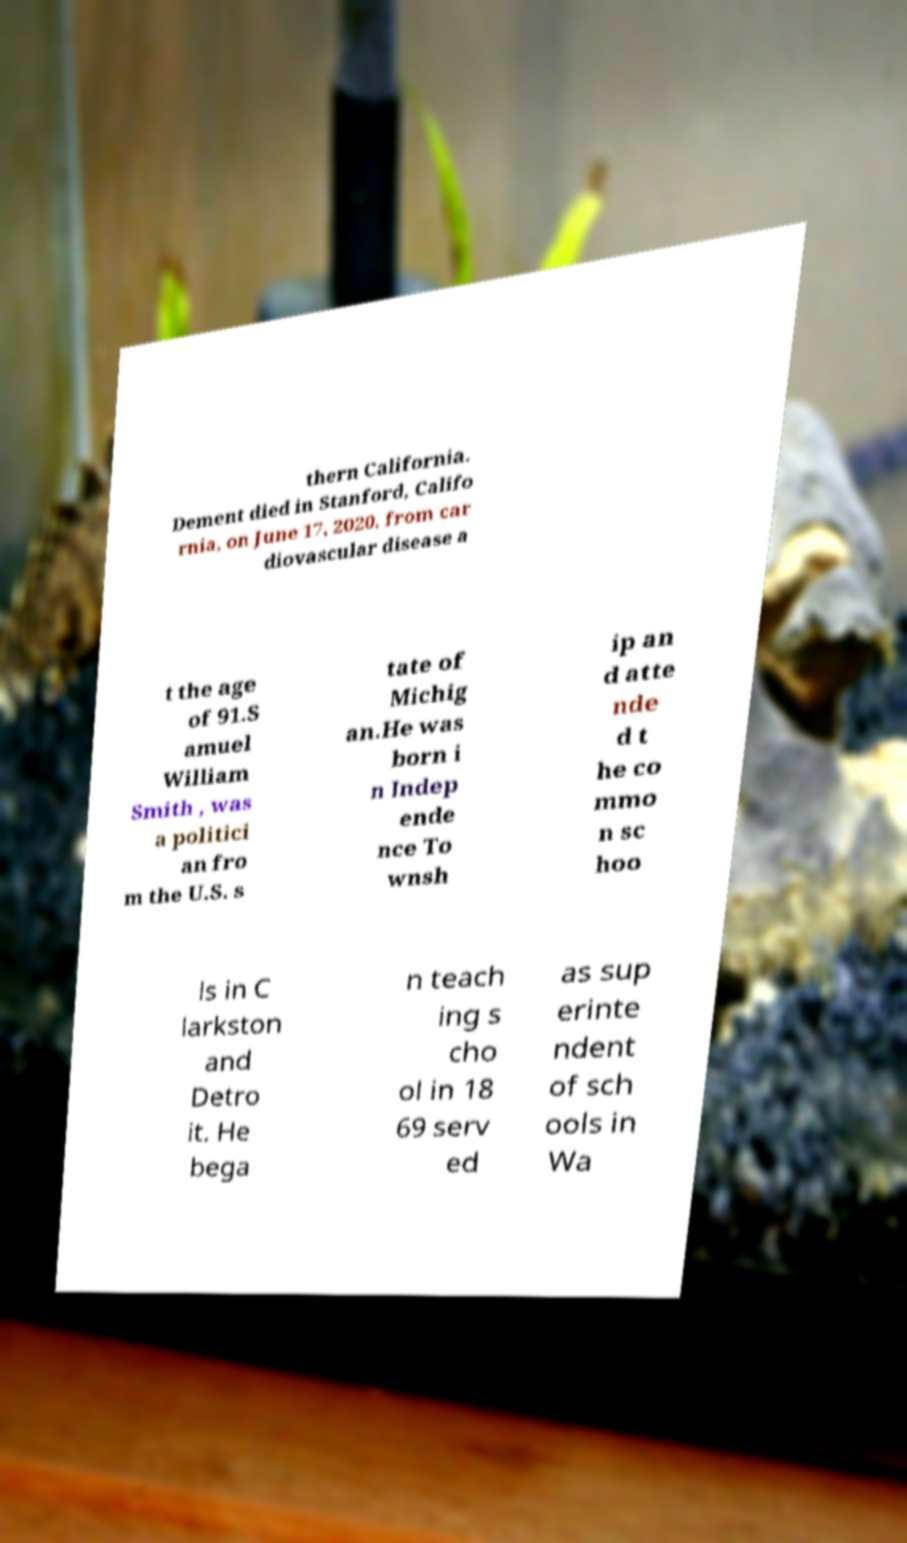Could you extract and type out the text from this image? thern California. Dement died in Stanford, Califo rnia, on June 17, 2020, from car diovascular disease a t the age of 91.S amuel William Smith , was a politici an fro m the U.S. s tate of Michig an.He was born i n Indep ende nce To wnsh ip an d atte nde d t he co mmo n sc hoo ls in C larkston and Detro it. He bega n teach ing s cho ol in 18 69 serv ed as sup erinte ndent of sch ools in Wa 